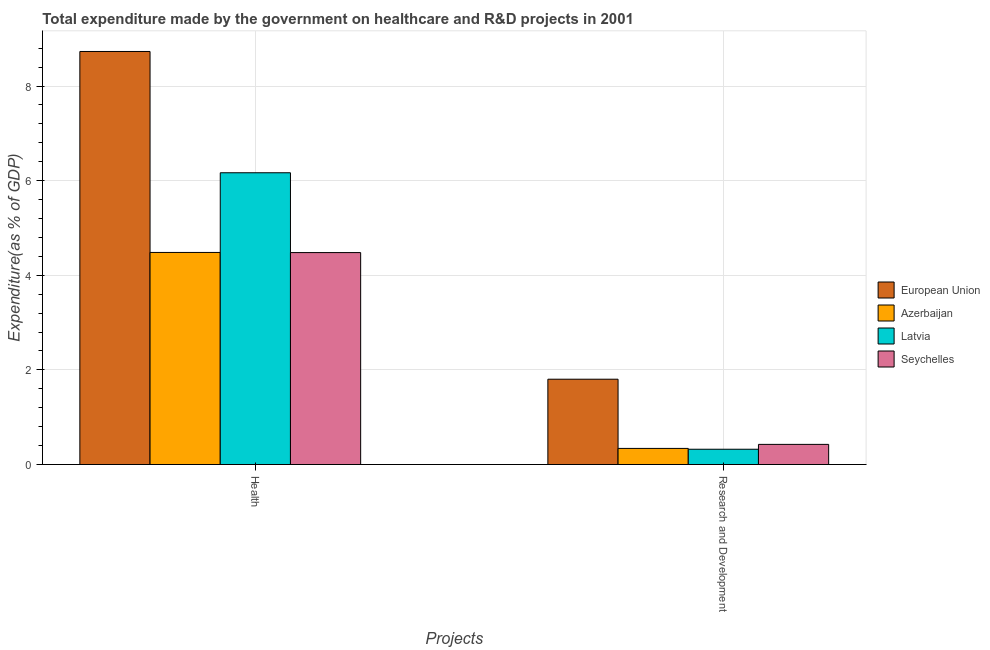How many groups of bars are there?
Offer a terse response. 2. Are the number of bars per tick equal to the number of legend labels?
Provide a short and direct response. Yes. What is the label of the 1st group of bars from the left?
Your answer should be compact. Health. What is the expenditure in r&d in Latvia?
Keep it short and to the point. 0.32. Across all countries, what is the maximum expenditure in r&d?
Offer a very short reply. 1.8. Across all countries, what is the minimum expenditure in r&d?
Provide a succinct answer. 0.32. In which country was the expenditure in healthcare minimum?
Give a very brief answer. Seychelles. What is the total expenditure in healthcare in the graph?
Your response must be concise. 23.86. What is the difference between the expenditure in r&d in Azerbaijan and that in Seychelles?
Keep it short and to the point. -0.09. What is the difference between the expenditure in r&d in Azerbaijan and the expenditure in healthcare in European Union?
Offer a very short reply. -8.39. What is the average expenditure in r&d per country?
Provide a short and direct response. 0.72. What is the difference between the expenditure in healthcare and expenditure in r&d in Latvia?
Your response must be concise. 5.84. What is the ratio of the expenditure in healthcare in Azerbaijan to that in Latvia?
Offer a terse response. 0.73. In how many countries, is the expenditure in healthcare greater than the average expenditure in healthcare taken over all countries?
Offer a very short reply. 2. What does the 4th bar from the left in Research and Development represents?
Give a very brief answer. Seychelles. What does the 4th bar from the right in Health represents?
Offer a terse response. European Union. How many bars are there?
Provide a short and direct response. 8. Are all the bars in the graph horizontal?
Provide a succinct answer. No. What is the difference between two consecutive major ticks on the Y-axis?
Offer a terse response. 2. Are the values on the major ticks of Y-axis written in scientific E-notation?
Your answer should be very brief. No. Does the graph contain any zero values?
Make the answer very short. No. What is the title of the graph?
Offer a very short reply. Total expenditure made by the government on healthcare and R&D projects in 2001. What is the label or title of the X-axis?
Offer a very short reply. Projects. What is the label or title of the Y-axis?
Offer a very short reply. Expenditure(as % of GDP). What is the Expenditure(as % of GDP) in European Union in Health?
Offer a very short reply. 8.73. What is the Expenditure(as % of GDP) of Azerbaijan in Health?
Keep it short and to the point. 4.48. What is the Expenditure(as % of GDP) in Latvia in Health?
Provide a succinct answer. 6.17. What is the Expenditure(as % of GDP) in Seychelles in Health?
Provide a succinct answer. 4.48. What is the Expenditure(as % of GDP) of European Union in Research and Development?
Offer a very short reply. 1.8. What is the Expenditure(as % of GDP) in Azerbaijan in Research and Development?
Give a very brief answer. 0.34. What is the Expenditure(as % of GDP) in Latvia in Research and Development?
Provide a short and direct response. 0.32. What is the Expenditure(as % of GDP) of Seychelles in Research and Development?
Keep it short and to the point. 0.43. Across all Projects, what is the maximum Expenditure(as % of GDP) of European Union?
Make the answer very short. 8.73. Across all Projects, what is the maximum Expenditure(as % of GDP) of Azerbaijan?
Keep it short and to the point. 4.48. Across all Projects, what is the maximum Expenditure(as % of GDP) of Latvia?
Offer a very short reply. 6.17. Across all Projects, what is the maximum Expenditure(as % of GDP) of Seychelles?
Keep it short and to the point. 4.48. Across all Projects, what is the minimum Expenditure(as % of GDP) in European Union?
Make the answer very short. 1.8. Across all Projects, what is the minimum Expenditure(as % of GDP) in Azerbaijan?
Your response must be concise. 0.34. Across all Projects, what is the minimum Expenditure(as % of GDP) in Latvia?
Your answer should be very brief. 0.32. Across all Projects, what is the minimum Expenditure(as % of GDP) of Seychelles?
Provide a succinct answer. 0.43. What is the total Expenditure(as % of GDP) in European Union in the graph?
Offer a terse response. 10.53. What is the total Expenditure(as % of GDP) of Azerbaijan in the graph?
Your answer should be compact. 4.82. What is the total Expenditure(as % of GDP) in Latvia in the graph?
Provide a short and direct response. 6.49. What is the total Expenditure(as % of GDP) in Seychelles in the graph?
Your answer should be compact. 4.9. What is the difference between the Expenditure(as % of GDP) of European Union in Health and that in Research and Development?
Offer a very short reply. 6.93. What is the difference between the Expenditure(as % of GDP) of Azerbaijan in Health and that in Research and Development?
Ensure brevity in your answer.  4.14. What is the difference between the Expenditure(as % of GDP) of Latvia in Health and that in Research and Development?
Offer a very short reply. 5.84. What is the difference between the Expenditure(as % of GDP) of Seychelles in Health and that in Research and Development?
Your answer should be compact. 4.05. What is the difference between the Expenditure(as % of GDP) in European Union in Health and the Expenditure(as % of GDP) in Azerbaijan in Research and Development?
Your answer should be compact. 8.39. What is the difference between the Expenditure(as % of GDP) in European Union in Health and the Expenditure(as % of GDP) in Latvia in Research and Development?
Ensure brevity in your answer.  8.41. What is the difference between the Expenditure(as % of GDP) in European Union in Health and the Expenditure(as % of GDP) in Seychelles in Research and Development?
Your answer should be compact. 8.31. What is the difference between the Expenditure(as % of GDP) of Azerbaijan in Health and the Expenditure(as % of GDP) of Latvia in Research and Development?
Keep it short and to the point. 4.16. What is the difference between the Expenditure(as % of GDP) of Azerbaijan in Health and the Expenditure(as % of GDP) of Seychelles in Research and Development?
Give a very brief answer. 4.06. What is the difference between the Expenditure(as % of GDP) in Latvia in Health and the Expenditure(as % of GDP) in Seychelles in Research and Development?
Your answer should be compact. 5.74. What is the average Expenditure(as % of GDP) in European Union per Projects?
Your answer should be compact. 5.27. What is the average Expenditure(as % of GDP) in Azerbaijan per Projects?
Ensure brevity in your answer.  2.41. What is the average Expenditure(as % of GDP) in Latvia per Projects?
Your answer should be very brief. 3.24. What is the average Expenditure(as % of GDP) of Seychelles per Projects?
Keep it short and to the point. 2.45. What is the difference between the Expenditure(as % of GDP) in European Union and Expenditure(as % of GDP) in Azerbaijan in Health?
Make the answer very short. 4.25. What is the difference between the Expenditure(as % of GDP) in European Union and Expenditure(as % of GDP) in Latvia in Health?
Provide a succinct answer. 2.56. What is the difference between the Expenditure(as % of GDP) in European Union and Expenditure(as % of GDP) in Seychelles in Health?
Provide a short and direct response. 4.25. What is the difference between the Expenditure(as % of GDP) in Azerbaijan and Expenditure(as % of GDP) in Latvia in Health?
Your answer should be compact. -1.68. What is the difference between the Expenditure(as % of GDP) of Azerbaijan and Expenditure(as % of GDP) of Seychelles in Health?
Keep it short and to the point. 0. What is the difference between the Expenditure(as % of GDP) in Latvia and Expenditure(as % of GDP) in Seychelles in Health?
Provide a short and direct response. 1.69. What is the difference between the Expenditure(as % of GDP) in European Union and Expenditure(as % of GDP) in Azerbaijan in Research and Development?
Provide a short and direct response. 1.46. What is the difference between the Expenditure(as % of GDP) in European Union and Expenditure(as % of GDP) in Latvia in Research and Development?
Offer a very short reply. 1.48. What is the difference between the Expenditure(as % of GDP) in European Union and Expenditure(as % of GDP) in Seychelles in Research and Development?
Give a very brief answer. 1.38. What is the difference between the Expenditure(as % of GDP) of Azerbaijan and Expenditure(as % of GDP) of Latvia in Research and Development?
Provide a succinct answer. 0.02. What is the difference between the Expenditure(as % of GDP) in Azerbaijan and Expenditure(as % of GDP) in Seychelles in Research and Development?
Your answer should be compact. -0.09. What is the difference between the Expenditure(as % of GDP) in Latvia and Expenditure(as % of GDP) in Seychelles in Research and Development?
Your answer should be very brief. -0.1. What is the ratio of the Expenditure(as % of GDP) in European Union in Health to that in Research and Development?
Keep it short and to the point. 4.84. What is the ratio of the Expenditure(as % of GDP) of Azerbaijan in Health to that in Research and Development?
Your answer should be compact. 13.18. What is the ratio of the Expenditure(as % of GDP) of Latvia in Health to that in Research and Development?
Your answer should be compact. 19.12. What is the ratio of the Expenditure(as % of GDP) of Seychelles in Health to that in Research and Development?
Offer a very short reply. 10.53. What is the difference between the highest and the second highest Expenditure(as % of GDP) of European Union?
Your answer should be compact. 6.93. What is the difference between the highest and the second highest Expenditure(as % of GDP) in Azerbaijan?
Provide a succinct answer. 4.14. What is the difference between the highest and the second highest Expenditure(as % of GDP) of Latvia?
Your answer should be compact. 5.84. What is the difference between the highest and the second highest Expenditure(as % of GDP) in Seychelles?
Give a very brief answer. 4.05. What is the difference between the highest and the lowest Expenditure(as % of GDP) of European Union?
Provide a succinct answer. 6.93. What is the difference between the highest and the lowest Expenditure(as % of GDP) of Azerbaijan?
Give a very brief answer. 4.14. What is the difference between the highest and the lowest Expenditure(as % of GDP) in Latvia?
Provide a succinct answer. 5.84. What is the difference between the highest and the lowest Expenditure(as % of GDP) in Seychelles?
Ensure brevity in your answer.  4.05. 